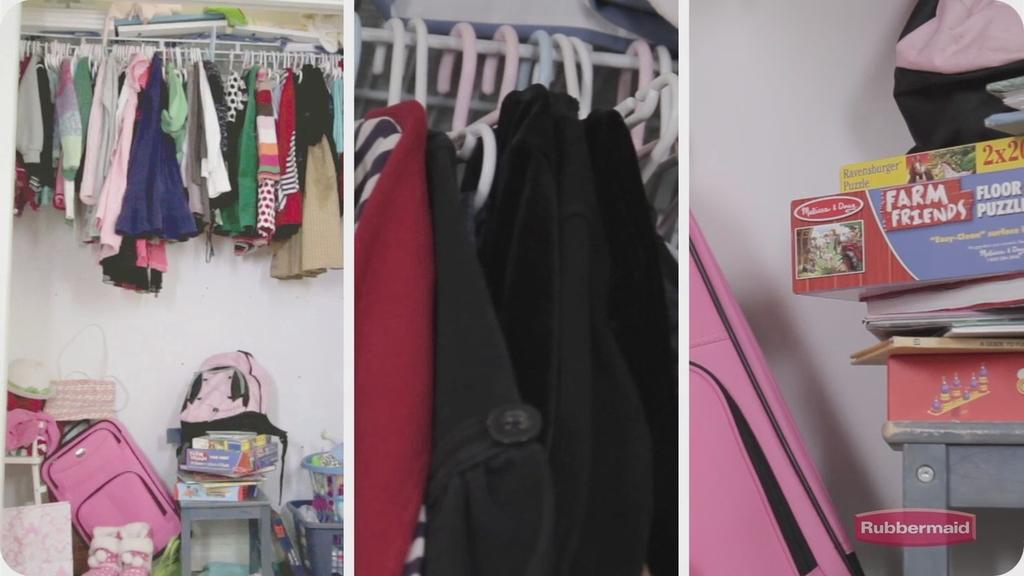<image>
Offer a succinct explanation of the picture presented. Farm Friends is the name of the game stored away in the closet. 